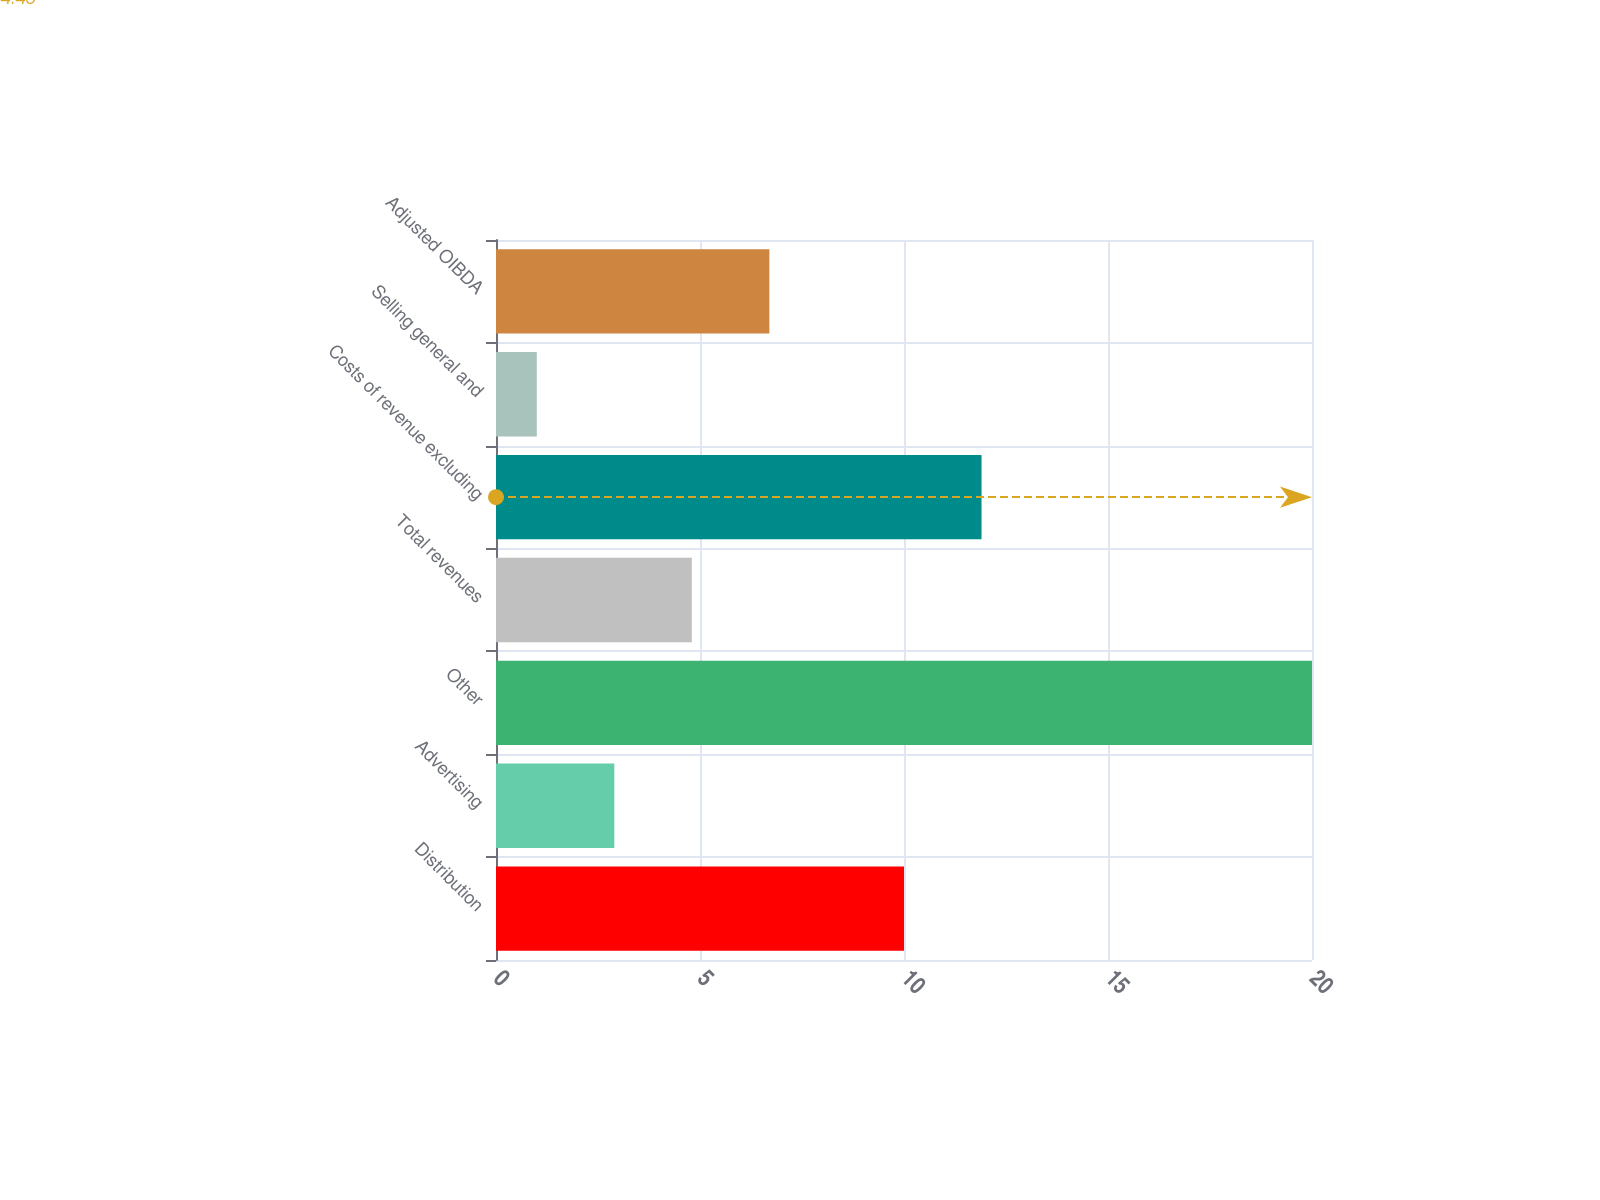Convert chart to OTSL. <chart><loc_0><loc_0><loc_500><loc_500><bar_chart><fcel>Distribution<fcel>Advertising<fcel>Other<fcel>Total revenues<fcel>Costs of revenue excluding<fcel>Selling general and<fcel>Adjusted OIBDA<nl><fcel>10<fcel>2.9<fcel>20<fcel>4.8<fcel>11.9<fcel>1<fcel>6.7<nl></chart> 